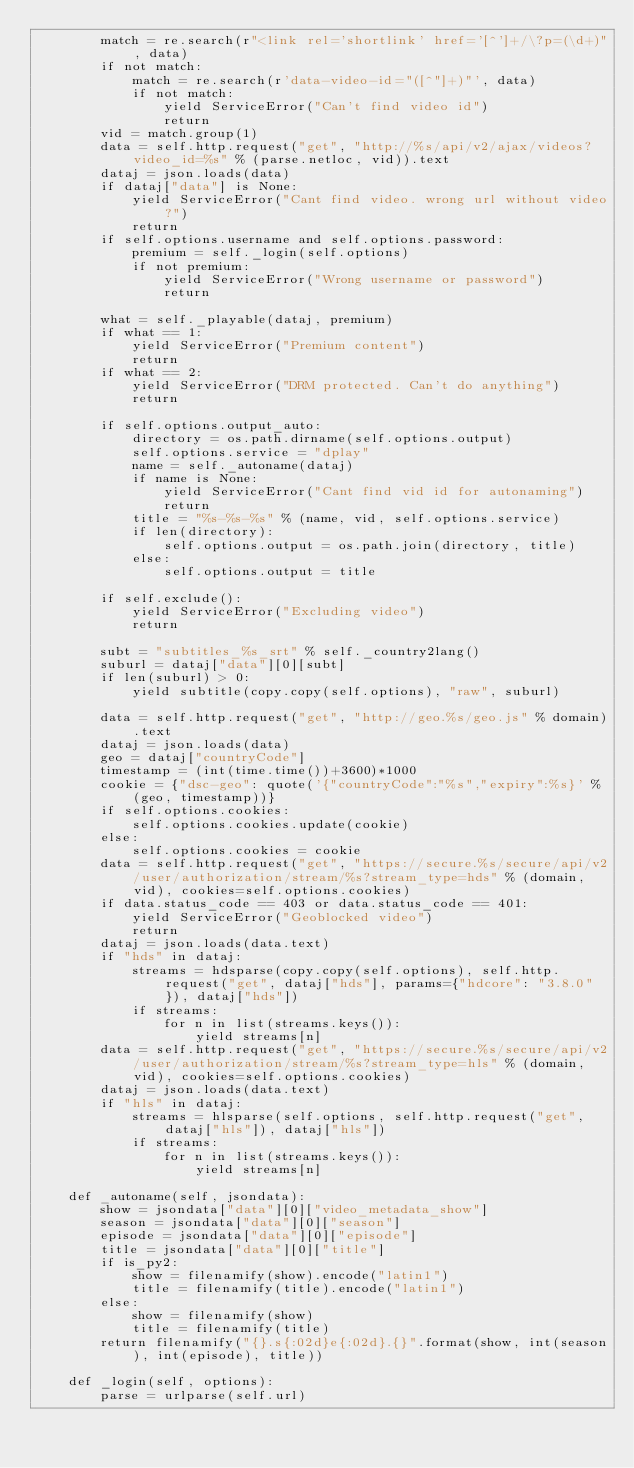Convert code to text. <code><loc_0><loc_0><loc_500><loc_500><_Python_>        match = re.search(r"<link rel='shortlink' href='[^']+/\?p=(\d+)", data)
        if not match:
            match = re.search(r'data-video-id="([^"]+)"', data)
            if not match:
                yield ServiceError("Can't find video id")
                return
        vid = match.group(1)
        data = self.http.request("get", "http://%s/api/v2/ajax/videos?video_id=%s" % (parse.netloc, vid)).text
        dataj = json.loads(data)
        if dataj["data"] is None:
            yield ServiceError("Cant find video. wrong url without video?")
            return
        if self.options.username and self.options.password:
            premium = self._login(self.options)
            if not premium:
                yield ServiceError("Wrong username or password")
                return

        what = self._playable(dataj, premium)
        if what == 1:
            yield ServiceError("Premium content")
            return
        if what == 2:
            yield ServiceError("DRM protected. Can't do anything")
            return

        if self.options.output_auto:
            directory = os.path.dirname(self.options.output)
            self.options.service = "dplay"
            name = self._autoname(dataj)
            if name is None:
                yield ServiceError("Cant find vid id for autonaming")
                return
            title = "%s-%s-%s" % (name, vid, self.options.service)
            if len(directory):
                self.options.output = os.path.join(directory, title)
            else:
                self.options.output = title

        if self.exclude():
            yield ServiceError("Excluding video")
            return

        subt = "subtitles_%s_srt" % self._country2lang()
        suburl = dataj["data"][0][subt]
        if len(suburl) > 0:
            yield subtitle(copy.copy(self.options), "raw", suburl)

        data = self.http.request("get", "http://geo.%s/geo.js" % domain).text
        dataj = json.loads(data)
        geo = dataj["countryCode"]
        timestamp = (int(time.time())+3600)*1000
        cookie = {"dsc-geo": quote('{"countryCode":"%s","expiry":%s}' % (geo, timestamp))}
        if self.options.cookies:
            self.options.cookies.update(cookie)
        else:
            self.options.cookies = cookie
        data = self.http.request("get", "https://secure.%s/secure/api/v2/user/authorization/stream/%s?stream_type=hds" % (domain, vid), cookies=self.options.cookies)
        if data.status_code == 403 or data.status_code == 401:
            yield ServiceError("Geoblocked video")
            return
        dataj = json.loads(data.text)
        if "hds" in dataj:
            streams = hdsparse(copy.copy(self.options), self.http.request("get", dataj["hds"], params={"hdcore": "3.8.0"}), dataj["hds"])
            if streams:
                for n in list(streams.keys()):
                    yield streams[n]
        data = self.http.request("get", "https://secure.%s/secure/api/v2/user/authorization/stream/%s?stream_type=hls" % (domain, vid), cookies=self.options.cookies)
        dataj = json.loads(data.text)
        if "hls" in dataj:
            streams = hlsparse(self.options, self.http.request("get", dataj["hls"]), dataj["hls"])
            if streams:
                for n in list(streams.keys()):
                    yield streams[n]

    def _autoname(self, jsondata):
        show = jsondata["data"][0]["video_metadata_show"]
        season = jsondata["data"][0]["season"]
        episode = jsondata["data"][0]["episode"]
        title = jsondata["data"][0]["title"]
        if is_py2:
            show = filenamify(show).encode("latin1")
            title = filenamify(title).encode("latin1")
        else:
            show = filenamify(show)
            title = filenamify(title)
        return filenamify("{}.s{:02d}e{:02d}.{}".format(show, int(season), int(episode), title))

    def _login(self, options):
        parse = urlparse(self.url)</code> 